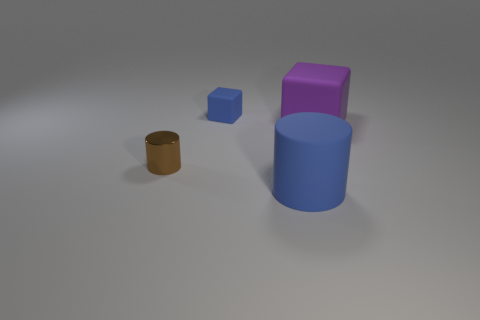Add 2 cubes. How many objects exist? 6 Add 4 brown cylinders. How many brown cylinders exist? 5 Subtract 0 cyan spheres. How many objects are left? 4 Subtract all small matte blocks. Subtract all tiny matte cubes. How many objects are left? 2 Add 1 tiny things. How many tiny things are left? 3 